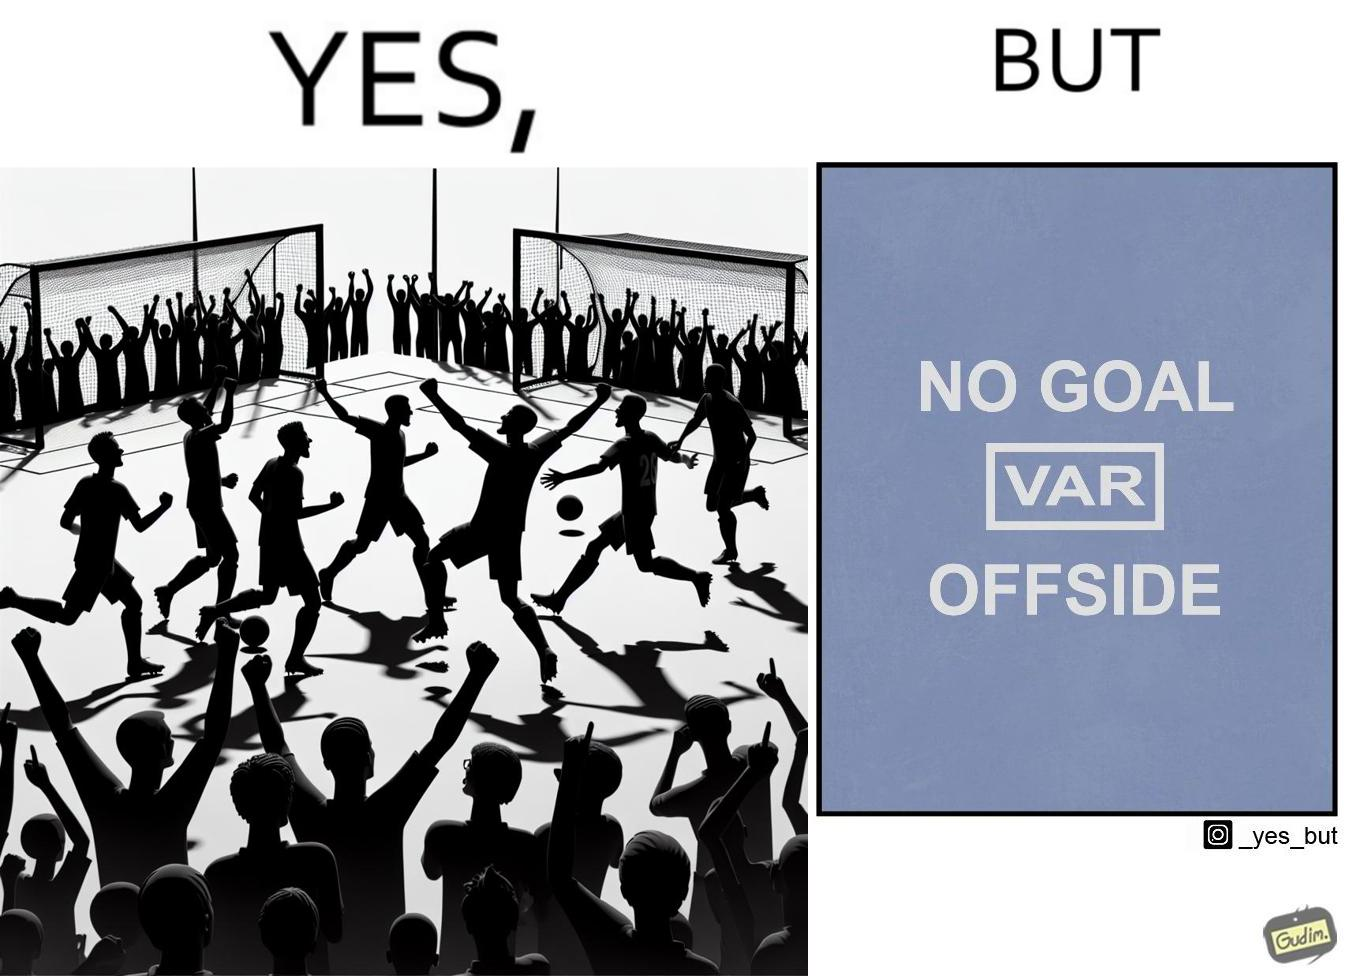Explain the humor or irony in this image. The image is ironical, as the team is celebrating as they think that they have scored a goal, but the sign on the screen says that it is an offside, and not a goal. This is a very common scenario in football matches. 